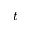Convert formula to latex. <formula><loc_0><loc_0><loc_500><loc_500>t</formula> 